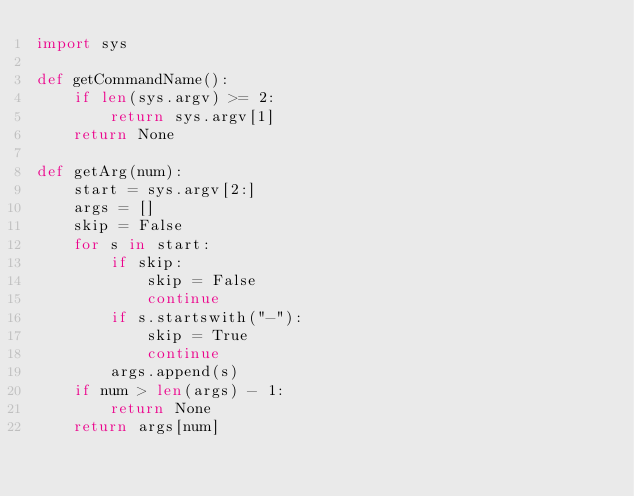Convert code to text. <code><loc_0><loc_0><loc_500><loc_500><_Python_>import sys

def getCommandName():
    if len(sys.argv) >= 2:
        return sys.argv[1]
    return None

def getArg(num):
    start = sys.argv[2:]
    args = []
    skip = False
    for s in start:
        if skip:
            skip = False
            continue
        if s.startswith("-"):
            skip = True
            continue
        args.append(s)
    if num > len(args) - 1:
        return None
    return args[num]
</code> 